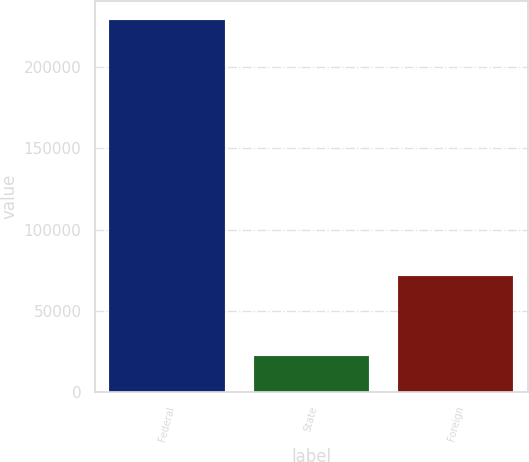Convert chart to OTSL. <chart><loc_0><loc_0><loc_500><loc_500><bar_chart><fcel>Federal<fcel>State<fcel>Foreign<nl><fcel>229224<fcel>22041<fcel>71507<nl></chart> 